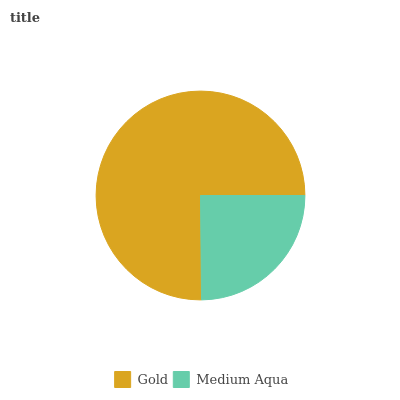Is Medium Aqua the minimum?
Answer yes or no. Yes. Is Gold the maximum?
Answer yes or no. Yes. Is Medium Aqua the maximum?
Answer yes or no. No. Is Gold greater than Medium Aqua?
Answer yes or no. Yes. Is Medium Aqua less than Gold?
Answer yes or no. Yes. Is Medium Aqua greater than Gold?
Answer yes or no. No. Is Gold less than Medium Aqua?
Answer yes or no. No. Is Gold the high median?
Answer yes or no. Yes. Is Medium Aqua the low median?
Answer yes or no. Yes. Is Medium Aqua the high median?
Answer yes or no. No. Is Gold the low median?
Answer yes or no. No. 